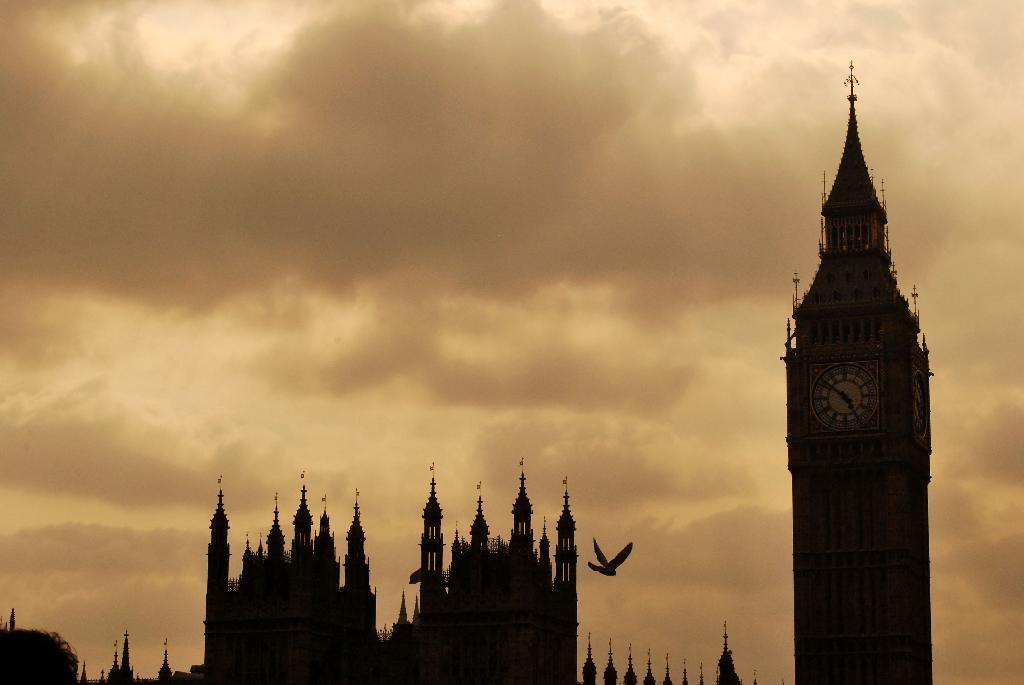What type of structures can be seen in the image? There are buildings in the image. Is there a specific building with a unique feature? Yes, there is a clock tower in the image. What is happening in the sky in the image? A bird is flying in the sky. What is the weather like in the image? The sky is cloudy in the image. What type of plane can be seen flying through the nose in the image? There is no plane or nose present in the image; it features buildings, a clock tower, a bird, and a cloudy sky. 